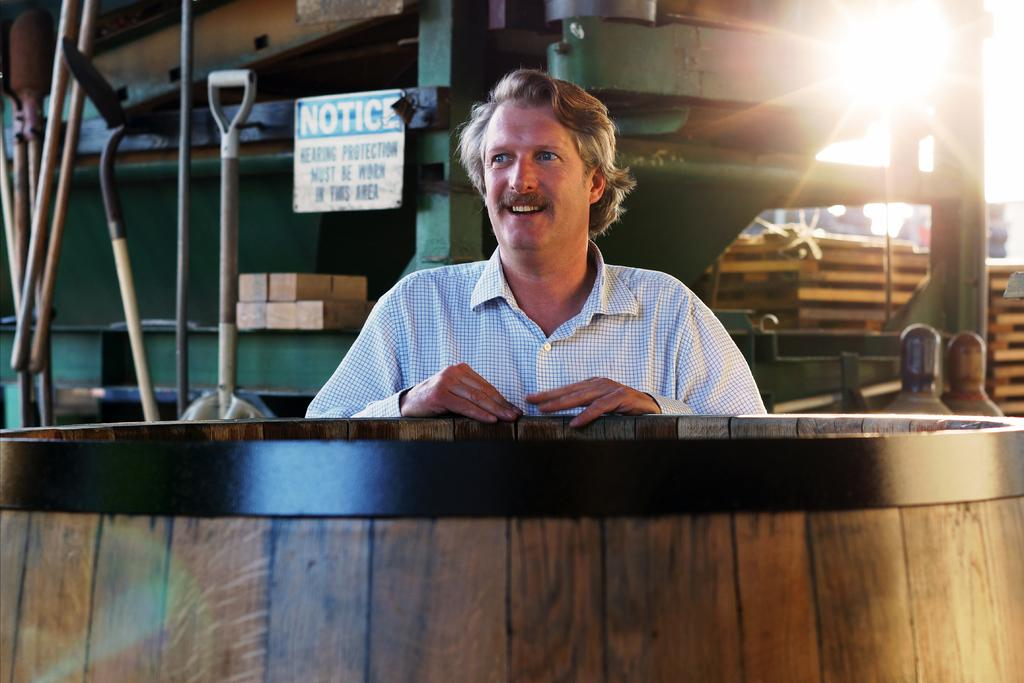Who is present in the image? There is a man in the image. What is the man wearing? The man is wearing a white shirt. What can be seen behind the man? The man is standing behind a wooden object. What colors can be seen in the background of the image? There is a white color notice and a green color machine in the background of the image. What type of robin can be seen sitting on the man's shoulder in the image? There is no robin present in the image; it only features a man, a wooden object, and the background elements. 